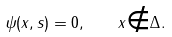<formula> <loc_0><loc_0><loc_500><loc_500>\psi ( x , s ) = 0 , \quad x { \notin } \Delta .</formula> 